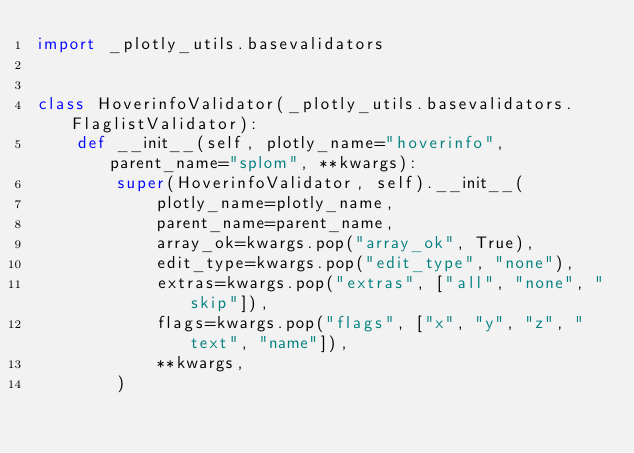<code> <loc_0><loc_0><loc_500><loc_500><_Python_>import _plotly_utils.basevalidators


class HoverinfoValidator(_plotly_utils.basevalidators.FlaglistValidator):
    def __init__(self, plotly_name="hoverinfo", parent_name="splom", **kwargs):
        super(HoverinfoValidator, self).__init__(
            plotly_name=plotly_name,
            parent_name=parent_name,
            array_ok=kwargs.pop("array_ok", True),
            edit_type=kwargs.pop("edit_type", "none"),
            extras=kwargs.pop("extras", ["all", "none", "skip"]),
            flags=kwargs.pop("flags", ["x", "y", "z", "text", "name"]),
            **kwargs,
        )
</code> 